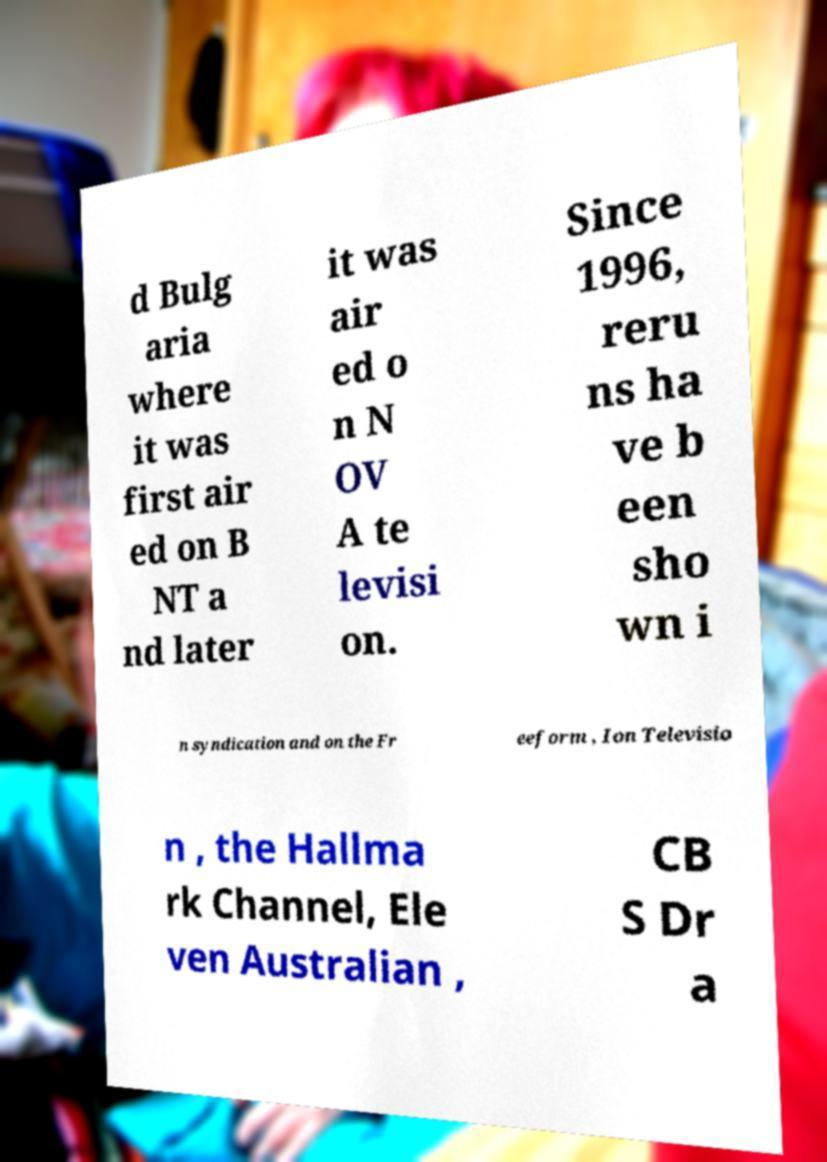What messages or text are displayed in this image? I need them in a readable, typed format. d Bulg aria where it was first air ed on B NT a nd later it was air ed o n N OV A te levisi on. Since 1996, reru ns ha ve b een sho wn i n syndication and on the Fr eeform , Ion Televisio n , the Hallma rk Channel, Ele ven Australian , CB S Dr a 